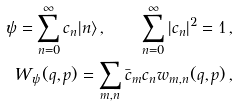<formula> <loc_0><loc_0><loc_500><loc_500>\psi = \sum _ { n = 0 } ^ { \infty } c _ { n } | n \rangle \, , \quad \sum _ { n = 0 } ^ { \infty } | c _ { n } | ^ { 2 } = 1 \, , \\ W _ { \psi } ( q , p ) = \sum _ { m , n } \bar { c } _ { m } c _ { n } w _ { m , n } ( q , p ) \, ,</formula> 